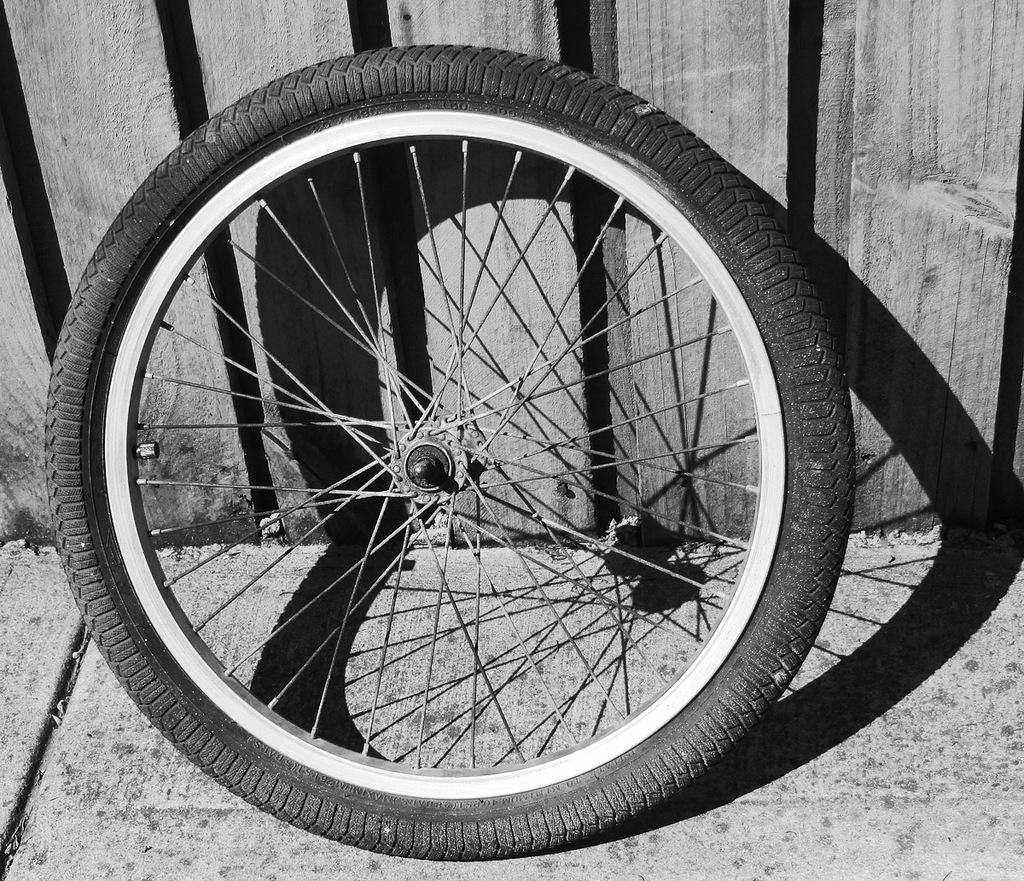What is the main object in the picture? There is a wheel in the picture. Can you describe the wheel in more detail? The wheel has spokes, a tire, and a rim. What can be seen in the background of the picture? There is a wooden wall in the background of the picture. What type of cloth is draped over the wheel in the image? There is no cloth draped over the wheel in the image; the wheel has spokes, a tire, and a rim. How many beads are attached to the spokes of the wheel in the image? There are no beads attached to the spokes of the wheel in the image; the wheel has spokes, a tire, and a rim. 